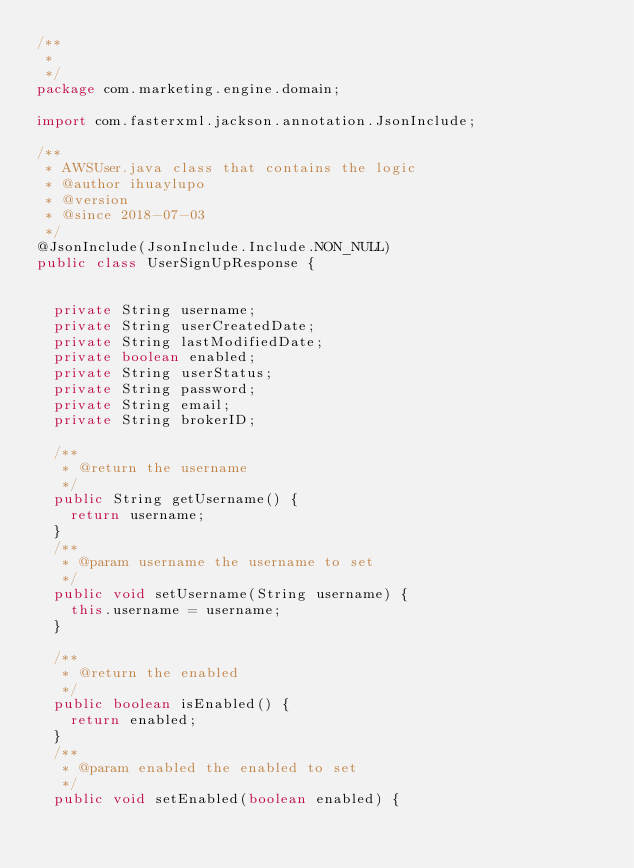Convert code to text. <code><loc_0><loc_0><loc_500><loc_500><_Java_>/**
 * 
 */
package com.marketing.engine.domain;

import com.fasterxml.jackson.annotation.JsonInclude;

/**
 * AWSUser.java class that contains the logic 
 * @author ihuaylupo
 * @version 
 * @since 2018-07-03 
 */
@JsonInclude(JsonInclude.Include.NON_NULL)
public class UserSignUpResponse {
	
	
	private String username;
	private String userCreatedDate;
	private String lastModifiedDate;
	private boolean enabled;
	private String userStatus;
	private String password;
	private String email;
	private String brokerID;
	
	/**
	 * @return the username
	 */
	public String getUsername() {
		return username;
	}
	/**
	 * @param username the username to set
	 */
	public void setUsername(String username) {
		this.username = username;
	}
	
	/**
	 * @return the enabled
	 */
	public boolean isEnabled() {
		return enabled;
	}
	/**
	 * @param enabled the enabled to set
	 */
	public void setEnabled(boolean enabled) {</code> 